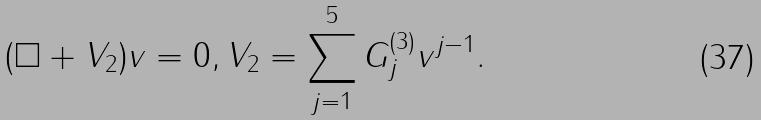Convert formula to latex. <formula><loc_0><loc_0><loc_500><loc_500>( \Box + V _ { 2 } ) v = 0 , V _ { 2 } = \sum _ { j = 1 } ^ { 5 } G _ { j } ^ { ( 3 ) } v ^ { j - 1 } .</formula> 